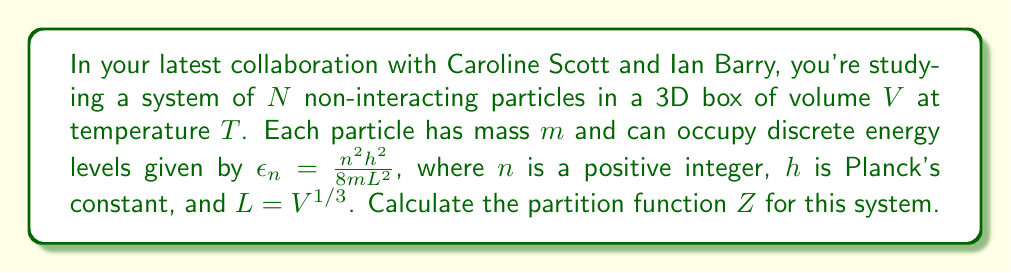Help me with this question. To calculate the partition function for this system, we'll follow these steps:

1) The partition function for a single particle is given by:

   $$Z_1 = \sum_{n=1}^{\infty} e^{-\beta\epsilon_n}$$

   where $\beta = \frac{1}{k_BT}$, and $k_B$ is Boltzmann's constant.

2) Substituting the energy levels:

   $$Z_1 = \sum_{n=1}^{\infty} e^{-\beta\frac{n^2h^2}{8mL^2}}$$

3) This sum can be approximated by an integral when the temperature is high enough:

   $$Z_1 \approx \int_0^{\infty} e^{-\beta\frac{n^2h^2}{8mL^2}} dn$$

4) This integral can be solved:

   $$Z_1 = L\sqrt{\frac{2\pi m k_B T}{h^2}}$$

5) For a 3D box, we need to consider all three dimensions, so we cube this result:

   $$Z_1 = V\left(\frac{2\pi m k_B T}{h^2}\right)^{3/2}$$

6) For $N$ non-interacting particles, the total partition function is the product of individual partition functions:

   $$Z = (Z_1)^N = V^N\left(\frac{2\pi m k_B T}{h^2}\right)^{3N/2}$$

This is the partition function for the system of $N$ non-interacting particles.
Answer: $$Z = V^N\left(\frac{2\pi m k_B T}{h^2}\right)^{3N/2}$$ 